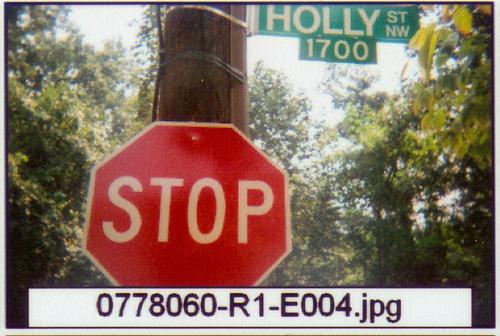Could this be a famous traffic stop?
Give a very brief answer. Yes. What color is the pole?
Keep it brief. Brown. What does the street sign say?
Be succinct. Stop. Where is the stop sign?
Write a very short answer. Pole. 